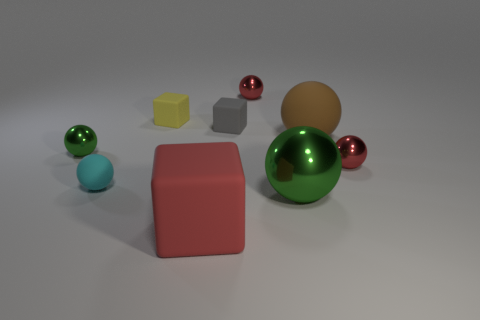What number of objects are either things that are behind the red rubber thing or green shiny objects that are in front of the big matte sphere?
Offer a terse response. 8. The red matte object that is the same size as the brown object is what shape?
Your answer should be compact. Cube. There is a gray thing that is the same material as the yellow thing; what size is it?
Ensure brevity in your answer.  Small. Is the tiny gray thing the same shape as the tiny green thing?
Offer a very short reply. No. There is another matte cube that is the same size as the yellow block; what is its color?
Offer a very short reply. Gray. What size is the yellow matte object that is the same shape as the gray rubber thing?
Give a very brief answer. Small. There is a shiny thing to the left of the large red matte block; what shape is it?
Give a very brief answer. Sphere. Do the small cyan rubber thing and the red thing that is in front of the cyan matte sphere have the same shape?
Give a very brief answer. No. Are there the same number of metallic objects left of the cyan matte sphere and large shiny things that are to the left of the tiny green ball?
Keep it short and to the point. No. What shape is the other shiny object that is the same color as the large shiny thing?
Ensure brevity in your answer.  Sphere. 